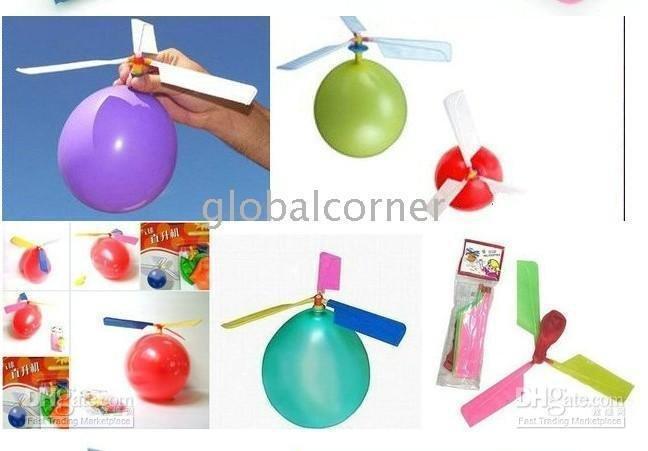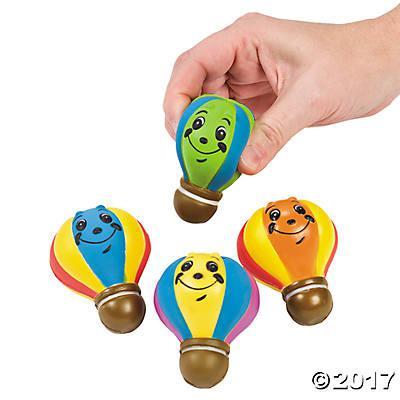The first image is the image on the left, the second image is the image on the right. Considering the images on both sides, is "One of the image has exactly four balloons." valid? Answer yes or no. Yes. 